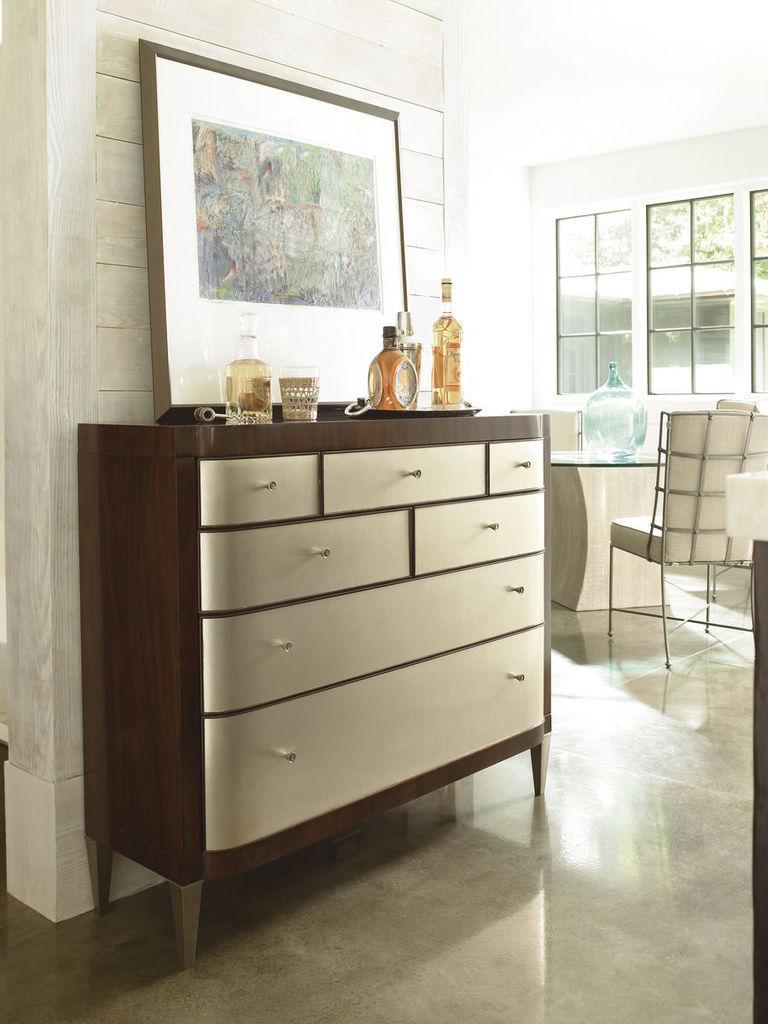In one or two sentences, can you explain what this image depicts? It is a living room , there is a cupboard above the cupboard there are some bottles and a glass and a photo frame, behind it there is a wooden wall, right to the table there are few chairs and a table , a window, in the background there are trees and a house. 